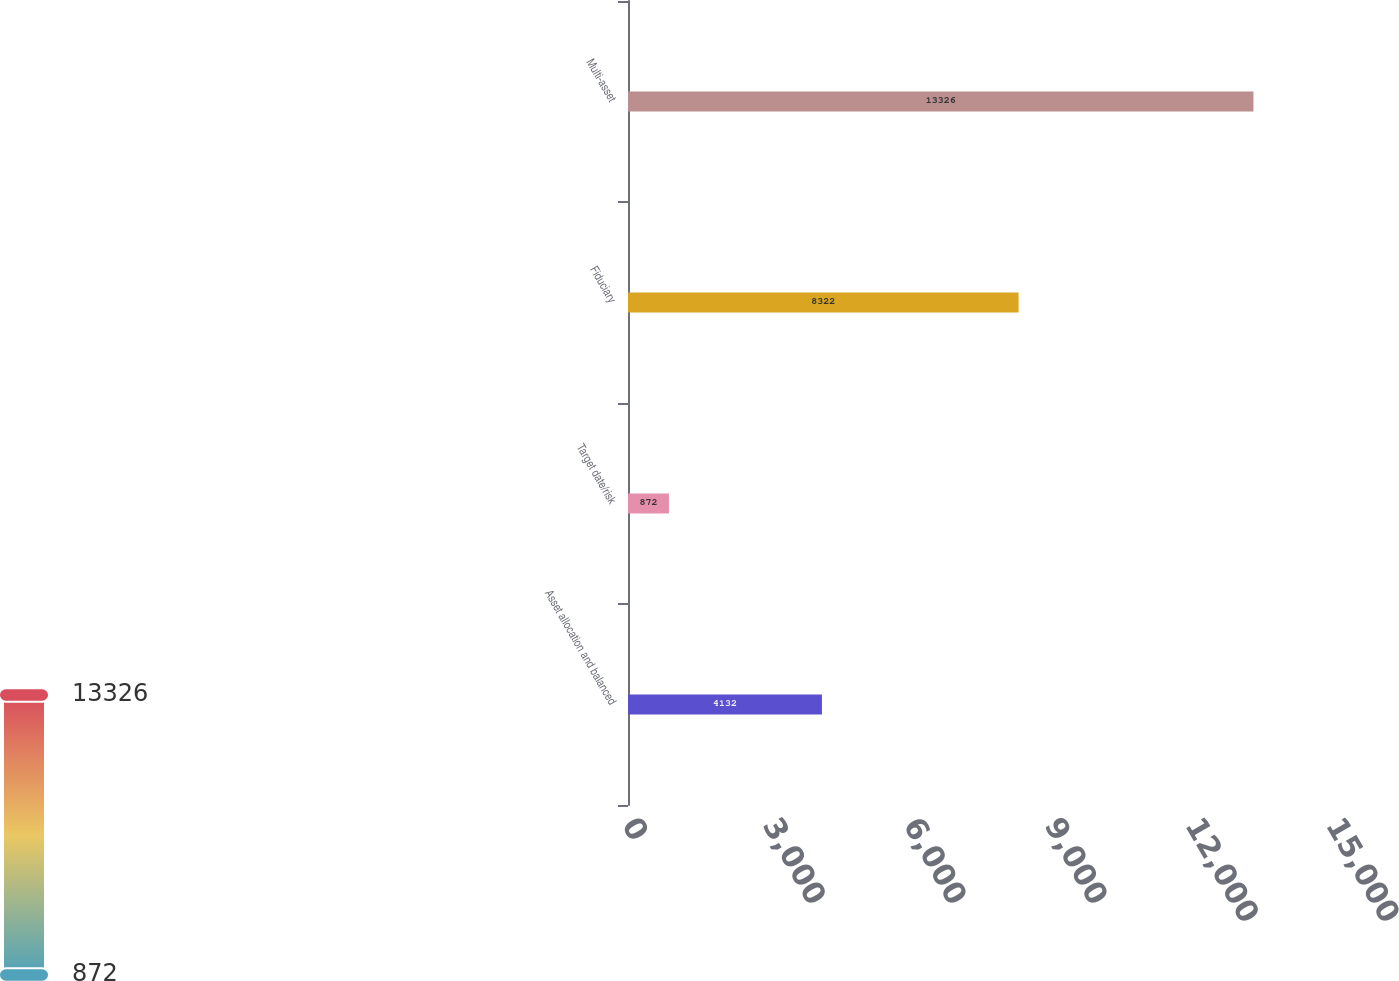<chart> <loc_0><loc_0><loc_500><loc_500><bar_chart><fcel>Asset allocation and balanced<fcel>Target date/risk<fcel>Fiduciary<fcel>Multi-asset<nl><fcel>4132<fcel>872<fcel>8322<fcel>13326<nl></chart> 